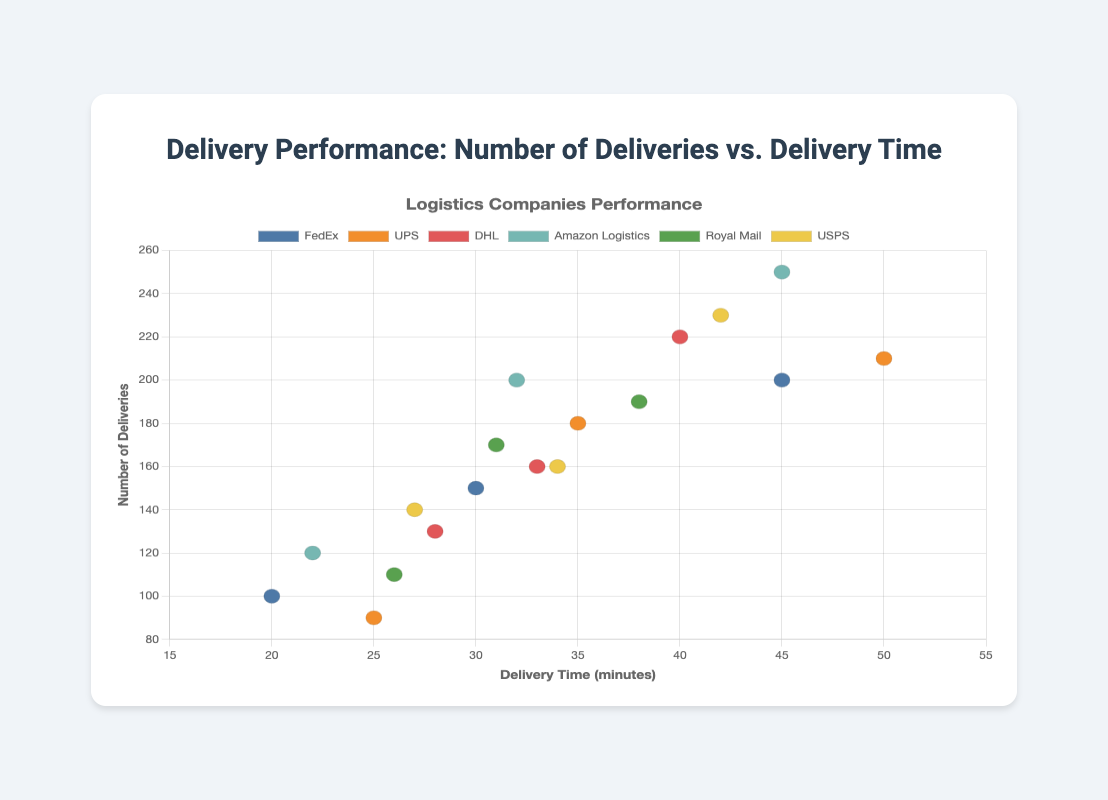How many logistics companies are represented in the scatter plot? There are six distinct color legends indicating six different logistics companies: FedEx, UPS, DHL, Amazon Logistics, Royal Mail, and USPS.
Answer: 6 Which logistics company has the highest number of deliveries? By looking at the y-axis (Number of Deliveries), Amazon Logistics has a data point at 250 deliveries, which is the highest among all companies.
Answer: Amazon Logistics What is the range of delivery times for UPS? The delivery times for UPS are observed at 25, 35, and 50 minutes. The range is the difference between the maximum and minimum values: 50 - 25.
Answer: 25 minutes Which company delivers the fewest number of shipments at the shortest delivery time? By examining the delivery times on the x-axis and the number of deliveries on the y-axis, FedEx has the fewest deliveries (100 deliveries in 20 minutes).
Answer: FedEx What is the average number of deliveries for DHL? DHL has deliveries of 160, 220, and 130. The sum of these deliveries is 510, and there are 3 data points, so the average is 510 / 3.
Answer: 170 Which company has data points with the least variation in delivery time? By comparing data points for delivery time (x-axis), DHL has data points at 28, 33, and 40 minutes, showing minimum variation between the points.
Answer: DHL Which two companies have their highest data points in terms of number of deliveries being almost the same? By looking at the y-axis values, Amazon Logistics and DHL both have high delivery numbers around 250 and 220 respectively, which are close to each other.
Answer: Amazon Logistics and DHL If you were to choose the company with the shortest average delivery time, which one would it be? Averaging times for each company: 
- FedEx: (30 + 45 + 20)/3 = 31.67 
- UPS: (35 + 50 + 25)/3 = 36.67 
- DHL: (33 + 40 + 28)/3 = 33.67 
- Amazon Logistics: (32 + 45 + 22)/3 = 33 
- Royal Mail: (31 + 38 + 26)/3 = 31.67
- USPS: (27 + 42 + 34)/3 = 34.33 
The lowest average is for both FedEx and Royal Mail at 31.67.
Answer: FedEx and Royal Mail Does Amazon Logistics ever have a delivery time of more than 45 minutes? By checking Amazon Logistics' data points on the x-axis (delivery time), the maximum delivery time for Amazon Logistics is 45 minutes, so no point exceeds 45 minutes.
Answer: No 